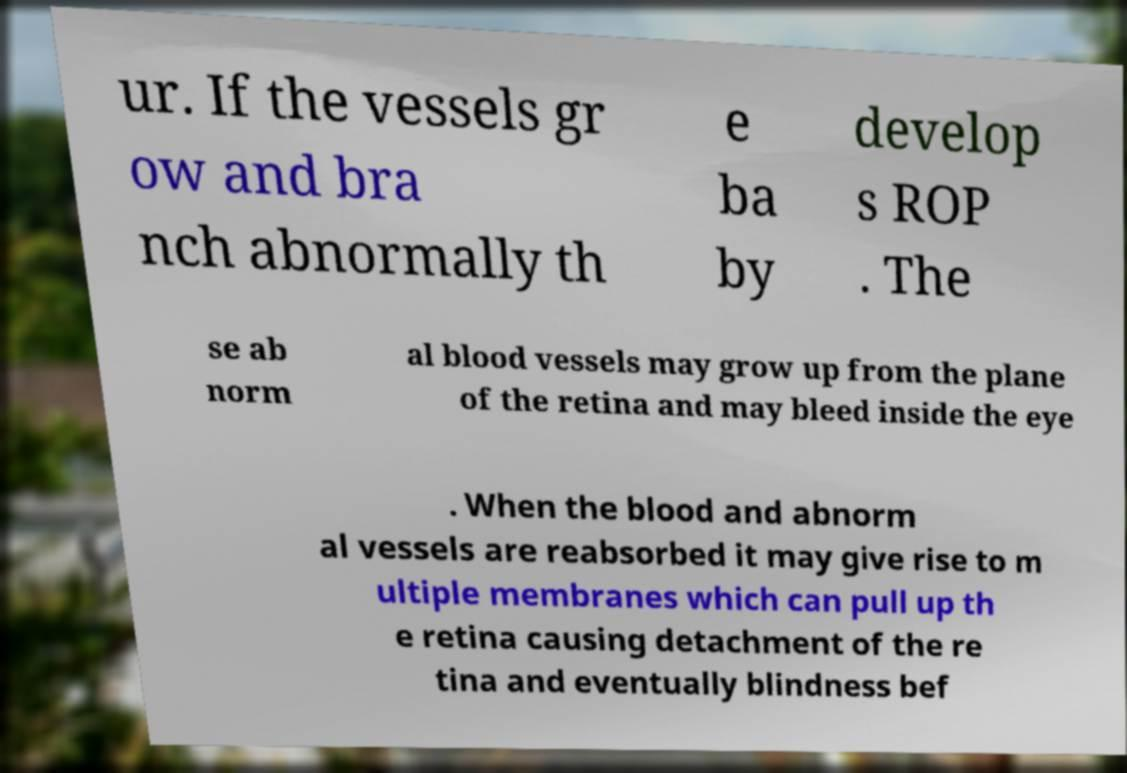Please identify and transcribe the text found in this image. ur. If the vessels gr ow and bra nch abnormally th e ba by develop s ROP . The se ab norm al blood vessels may grow up from the plane of the retina and may bleed inside the eye . When the blood and abnorm al vessels are reabsorbed it may give rise to m ultiple membranes which can pull up th e retina causing detachment of the re tina and eventually blindness bef 